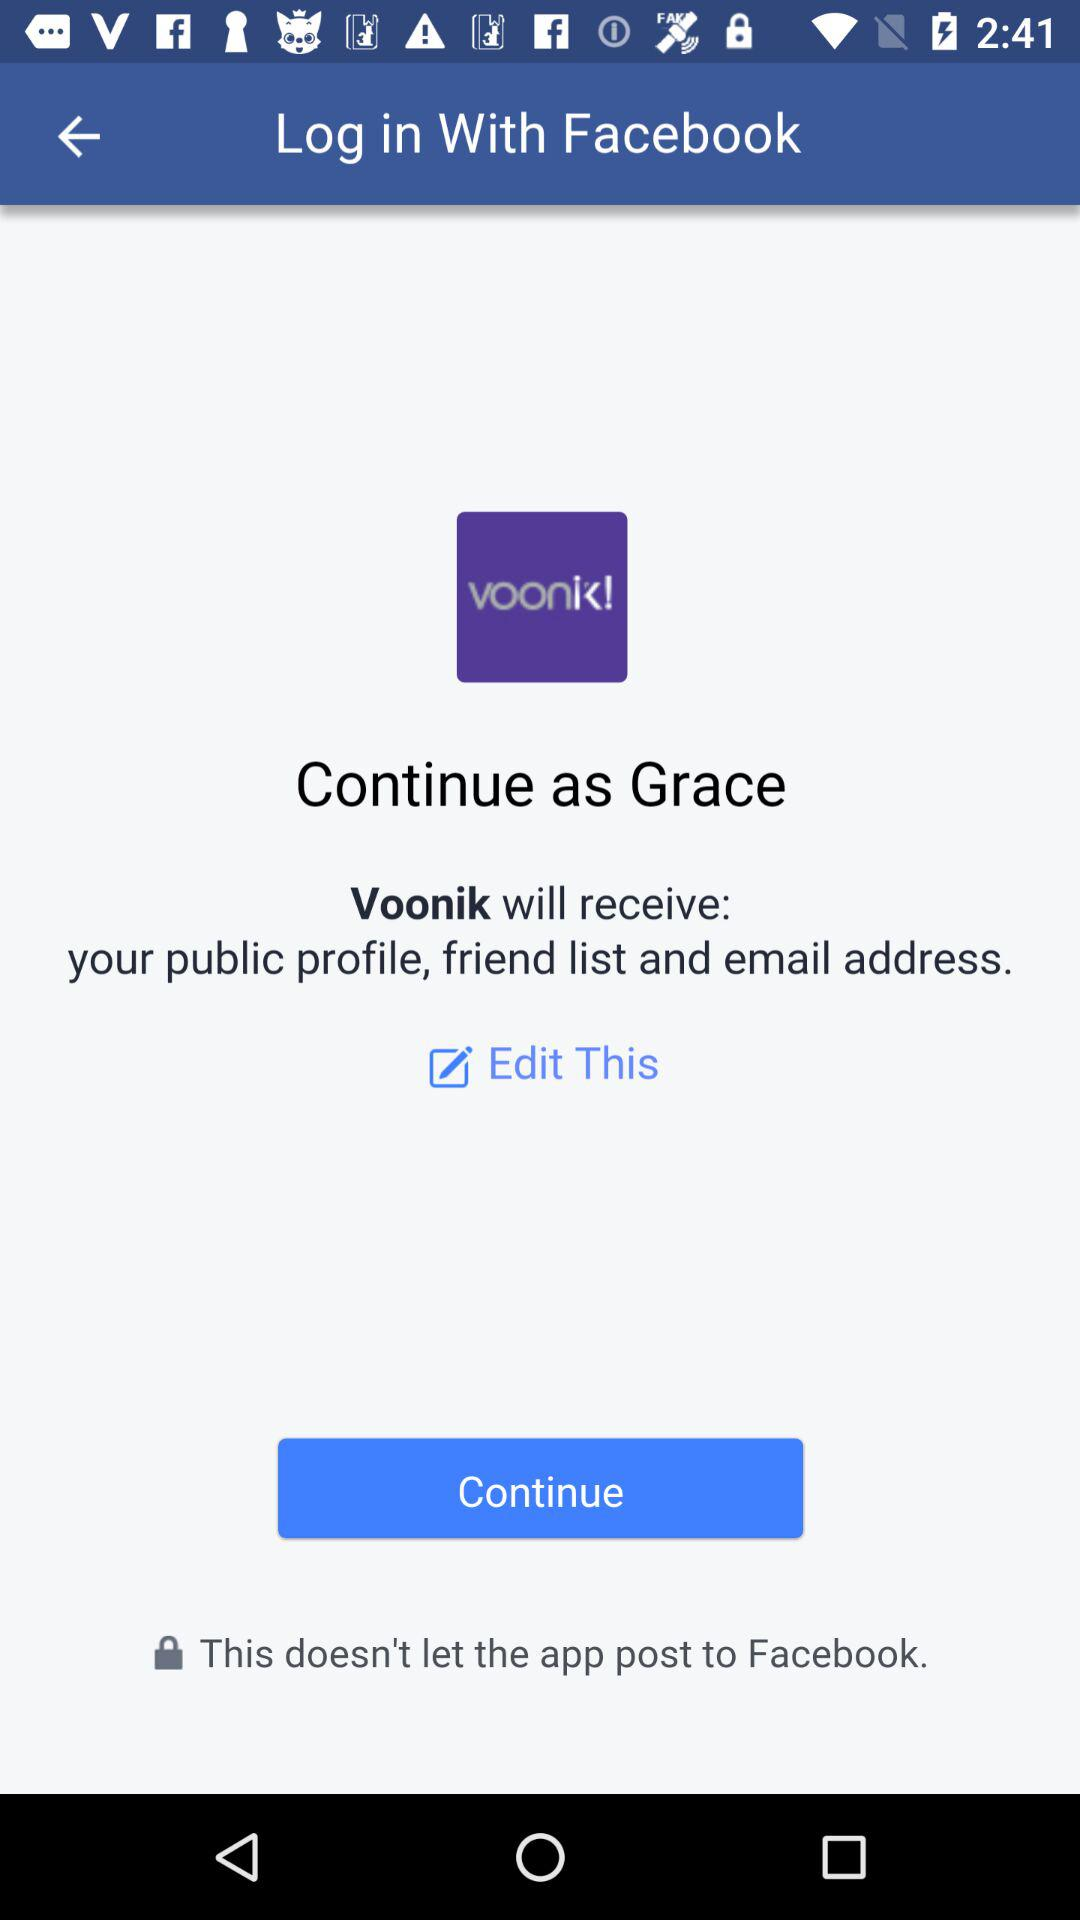What application will receive my public profile, email address and friend list? The application that will receive your public profile, email address and friend list is "Voonik". 